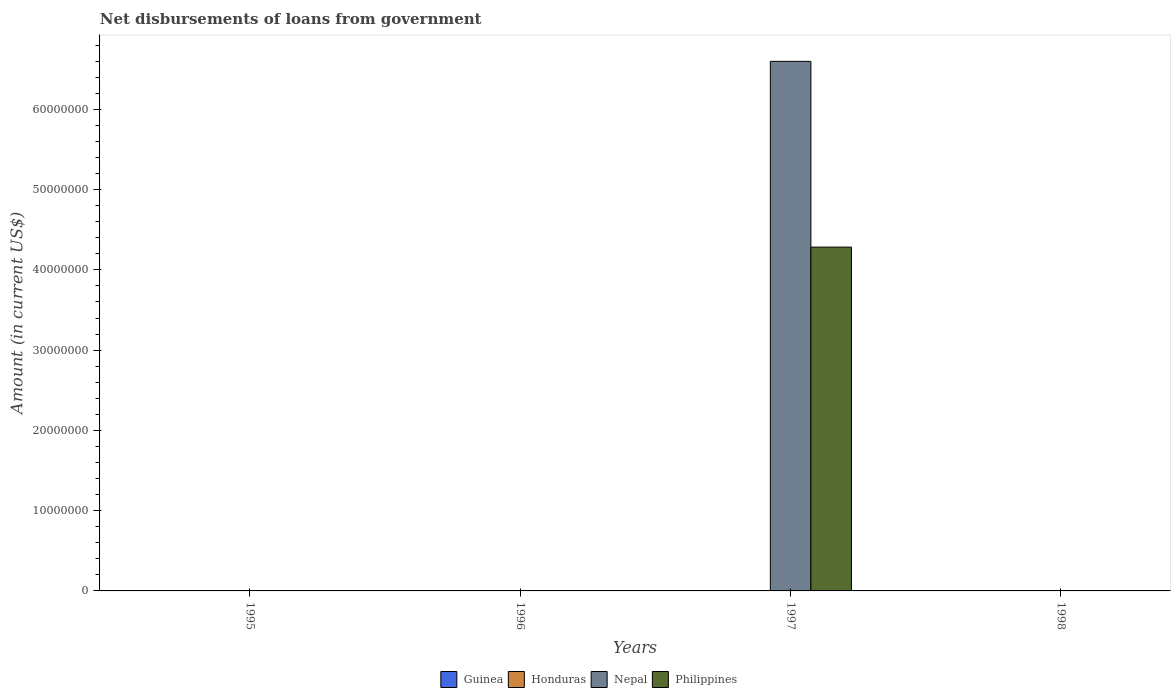How many different coloured bars are there?
Offer a very short reply. 2. How many bars are there on the 1st tick from the right?
Provide a short and direct response. 0. What is the label of the 3rd group of bars from the left?
Your answer should be very brief. 1997. What is the amount of loan disbursed from government in Honduras in 1996?
Make the answer very short. 0. Across all years, what is the maximum amount of loan disbursed from government in Nepal?
Provide a succinct answer. 6.60e+07. In which year was the amount of loan disbursed from government in Nepal maximum?
Provide a succinct answer. 1997. What is the total amount of loan disbursed from government in Guinea in the graph?
Ensure brevity in your answer.  0. What is the difference between the amount of loan disbursed from government in Honduras in 1997 and the amount of loan disbursed from government in Guinea in 1995?
Keep it short and to the point. 0. What is the average amount of loan disbursed from government in Guinea per year?
Offer a very short reply. 0. What is the difference between the highest and the lowest amount of loan disbursed from government in Nepal?
Provide a short and direct response. 6.60e+07. Is it the case that in every year, the sum of the amount of loan disbursed from government in Honduras and amount of loan disbursed from government in Nepal is greater than the sum of amount of loan disbursed from government in Guinea and amount of loan disbursed from government in Philippines?
Give a very brief answer. No. What is the difference between two consecutive major ticks on the Y-axis?
Offer a very short reply. 1.00e+07. Are the values on the major ticks of Y-axis written in scientific E-notation?
Your response must be concise. No. Does the graph contain grids?
Provide a succinct answer. No. What is the title of the graph?
Your answer should be compact. Net disbursements of loans from government. Does "Andorra" appear as one of the legend labels in the graph?
Provide a short and direct response. No. What is the label or title of the X-axis?
Your response must be concise. Years. What is the Amount (in current US$) of Guinea in 1995?
Your response must be concise. 0. What is the Amount (in current US$) in Nepal in 1995?
Your answer should be very brief. 0. What is the Amount (in current US$) of Philippines in 1995?
Make the answer very short. 0. What is the Amount (in current US$) of Guinea in 1996?
Ensure brevity in your answer.  0. What is the Amount (in current US$) of Honduras in 1996?
Offer a terse response. 0. What is the Amount (in current US$) of Nepal in 1996?
Ensure brevity in your answer.  0. What is the Amount (in current US$) of Nepal in 1997?
Provide a succinct answer. 6.60e+07. What is the Amount (in current US$) of Philippines in 1997?
Your answer should be compact. 4.28e+07. What is the Amount (in current US$) of Guinea in 1998?
Offer a terse response. 0. What is the Amount (in current US$) of Honduras in 1998?
Your answer should be compact. 0. Across all years, what is the maximum Amount (in current US$) of Nepal?
Your answer should be compact. 6.60e+07. Across all years, what is the maximum Amount (in current US$) in Philippines?
Make the answer very short. 4.28e+07. Across all years, what is the minimum Amount (in current US$) of Nepal?
Your response must be concise. 0. What is the total Amount (in current US$) in Honduras in the graph?
Give a very brief answer. 0. What is the total Amount (in current US$) of Nepal in the graph?
Keep it short and to the point. 6.60e+07. What is the total Amount (in current US$) of Philippines in the graph?
Offer a very short reply. 4.28e+07. What is the average Amount (in current US$) of Guinea per year?
Offer a very short reply. 0. What is the average Amount (in current US$) in Honduras per year?
Provide a succinct answer. 0. What is the average Amount (in current US$) of Nepal per year?
Make the answer very short. 1.65e+07. What is the average Amount (in current US$) in Philippines per year?
Provide a short and direct response. 1.07e+07. In the year 1997, what is the difference between the Amount (in current US$) of Nepal and Amount (in current US$) of Philippines?
Offer a terse response. 2.31e+07. What is the difference between the highest and the lowest Amount (in current US$) of Nepal?
Ensure brevity in your answer.  6.60e+07. What is the difference between the highest and the lowest Amount (in current US$) in Philippines?
Your answer should be compact. 4.28e+07. 